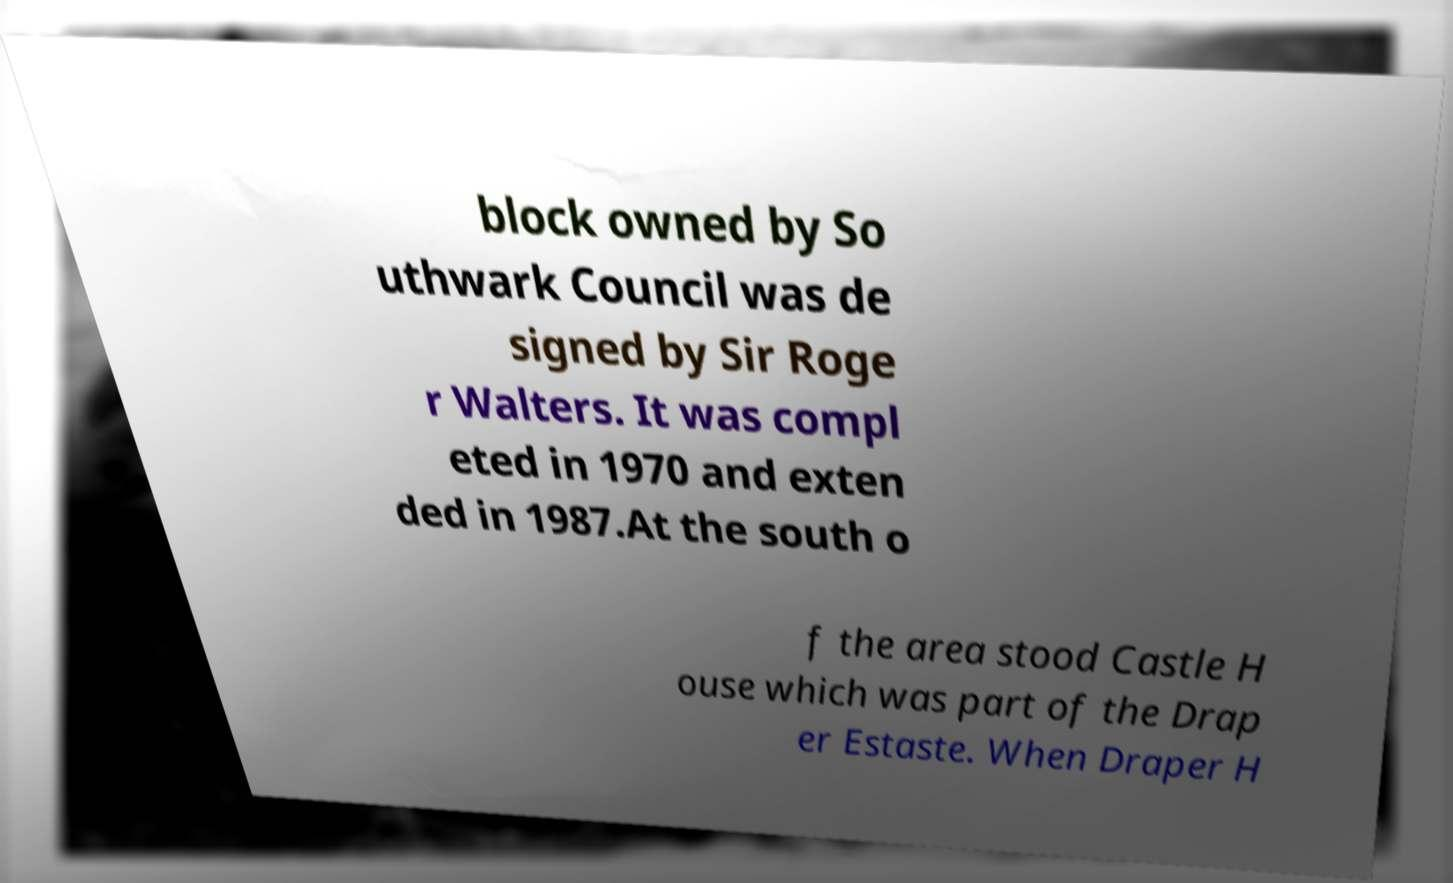Can you read and provide the text displayed in the image?This photo seems to have some interesting text. Can you extract and type it out for me? block owned by So uthwark Council was de signed by Sir Roge r Walters. It was compl eted in 1970 and exten ded in 1987.At the south o f the area stood Castle H ouse which was part of the Drap er Estaste. When Draper H 